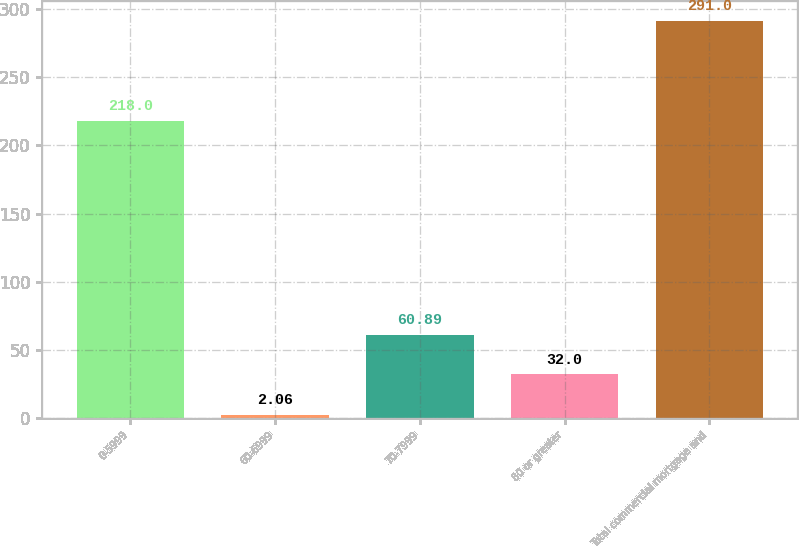Convert chart to OTSL. <chart><loc_0><loc_0><loc_500><loc_500><bar_chart><fcel>0-5999<fcel>60-6999<fcel>70-7999<fcel>80 or greater<fcel>Total commercial mortgage and<nl><fcel>218<fcel>2.06<fcel>60.89<fcel>32<fcel>291<nl></chart> 